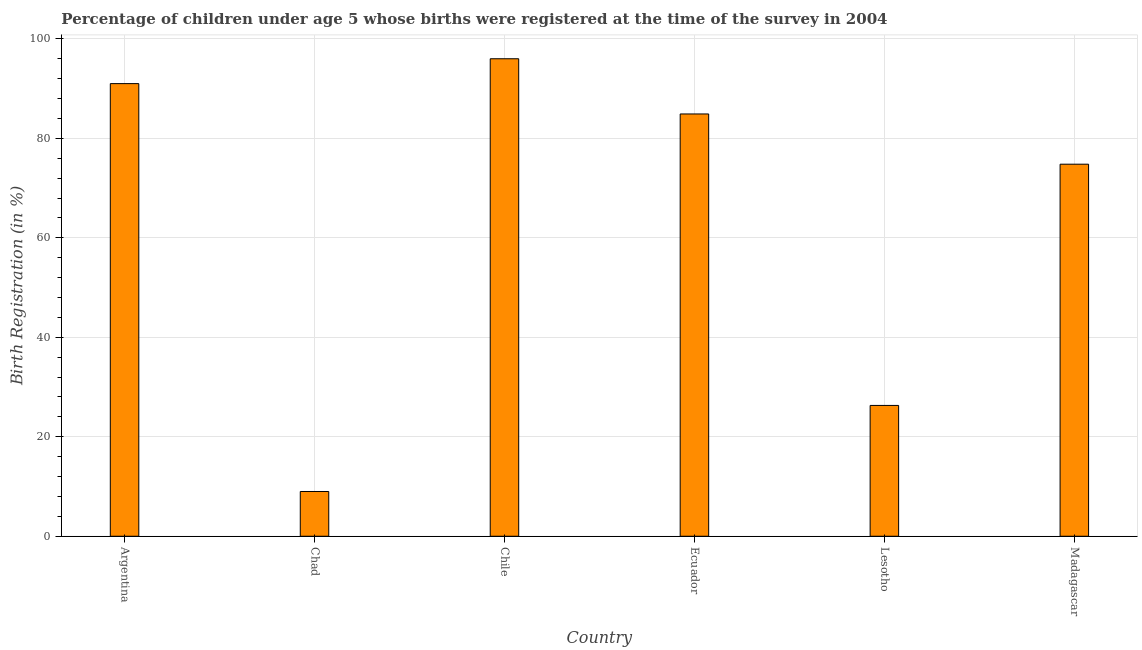Does the graph contain grids?
Provide a short and direct response. Yes. What is the title of the graph?
Offer a terse response. Percentage of children under age 5 whose births were registered at the time of the survey in 2004. What is the label or title of the X-axis?
Give a very brief answer. Country. What is the label or title of the Y-axis?
Your response must be concise. Birth Registration (in %). What is the birth registration in Lesotho?
Ensure brevity in your answer.  26.3. Across all countries, what is the maximum birth registration?
Provide a short and direct response. 96. In which country was the birth registration minimum?
Your response must be concise. Chad. What is the sum of the birth registration?
Give a very brief answer. 382. What is the difference between the birth registration in Ecuador and Madagascar?
Your answer should be very brief. 10.1. What is the average birth registration per country?
Ensure brevity in your answer.  63.67. What is the median birth registration?
Offer a terse response. 79.85. In how many countries, is the birth registration greater than 12 %?
Offer a very short reply. 5. What is the ratio of the birth registration in Lesotho to that in Madagascar?
Ensure brevity in your answer.  0.35. Is the sum of the birth registration in Argentina and Chile greater than the maximum birth registration across all countries?
Ensure brevity in your answer.  Yes. In how many countries, is the birth registration greater than the average birth registration taken over all countries?
Make the answer very short. 4. What is the difference between two consecutive major ticks on the Y-axis?
Provide a succinct answer. 20. Are the values on the major ticks of Y-axis written in scientific E-notation?
Offer a very short reply. No. What is the Birth Registration (in %) in Argentina?
Keep it short and to the point. 91. What is the Birth Registration (in %) in Chad?
Your response must be concise. 9. What is the Birth Registration (in %) in Chile?
Offer a very short reply. 96. What is the Birth Registration (in %) of Ecuador?
Give a very brief answer. 84.9. What is the Birth Registration (in %) of Lesotho?
Your answer should be very brief. 26.3. What is the Birth Registration (in %) in Madagascar?
Your response must be concise. 74.8. What is the difference between the Birth Registration (in %) in Argentina and Chad?
Your answer should be very brief. 82. What is the difference between the Birth Registration (in %) in Argentina and Ecuador?
Provide a short and direct response. 6.1. What is the difference between the Birth Registration (in %) in Argentina and Lesotho?
Ensure brevity in your answer.  64.7. What is the difference between the Birth Registration (in %) in Argentina and Madagascar?
Make the answer very short. 16.2. What is the difference between the Birth Registration (in %) in Chad and Chile?
Ensure brevity in your answer.  -87. What is the difference between the Birth Registration (in %) in Chad and Ecuador?
Provide a succinct answer. -75.9. What is the difference between the Birth Registration (in %) in Chad and Lesotho?
Your response must be concise. -17.3. What is the difference between the Birth Registration (in %) in Chad and Madagascar?
Offer a terse response. -65.8. What is the difference between the Birth Registration (in %) in Chile and Ecuador?
Make the answer very short. 11.1. What is the difference between the Birth Registration (in %) in Chile and Lesotho?
Make the answer very short. 69.7. What is the difference between the Birth Registration (in %) in Chile and Madagascar?
Ensure brevity in your answer.  21.2. What is the difference between the Birth Registration (in %) in Ecuador and Lesotho?
Keep it short and to the point. 58.6. What is the difference between the Birth Registration (in %) in Lesotho and Madagascar?
Give a very brief answer. -48.5. What is the ratio of the Birth Registration (in %) in Argentina to that in Chad?
Offer a very short reply. 10.11. What is the ratio of the Birth Registration (in %) in Argentina to that in Chile?
Give a very brief answer. 0.95. What is the ratio of the Birth Registration (in %) in Argentina to that in Ecuador?
Make the answer very short. 1.07. What is the ratio of the Birth Registration (in %) in Argentina to that in Lesotho?
Offer a very short reply. 3.46. What is the ratio of the Birth Registration (in %) in Argentina to that in Madagascar?
Keep it short and to the point. 1.22. What is the ratio of the Birth Registration (in %) in Chad to that in Chile?
Your answer should be very brief. 0.09. What is the ratio of the Birth Registration (in %) in Chad to that in Ecuador?
Your response must be concise. 0.11. What is the ratio of the Birth Registration (in %) in Chad to that in Lesotho?
Your answer should be compact. 0.34. What is the ratio of the Birth Registration (in %) in Chad to that in Madagascar?
Offer a terse response. 0.12. What is the ratio of the Birth Registration (in %) in Chile to that in Ecuador?
Your answer should be compact. 1.13. What is the ratio of the Birth Registration (in %) in Chile to that in Lesotho?
Your response must be concise. 3.65. What is the ratio of the Birth Registration (in %) in Chile to that in Madagascar?
Give a very brief answer. 1.28. What is the ratio of the Birth Registration (in %) in Ecuador to that in Lesotho?
Your response must be concise. 3.23. What is the ratio of the Birth Registration (in %) in Ecuador to that in Madagascar?
Keep it short and to the point. 1.14. What is the ratio of the Birth Registration (in %) in Lesotho to that in Madagascar?
Give a very brief answer. 0.35. 